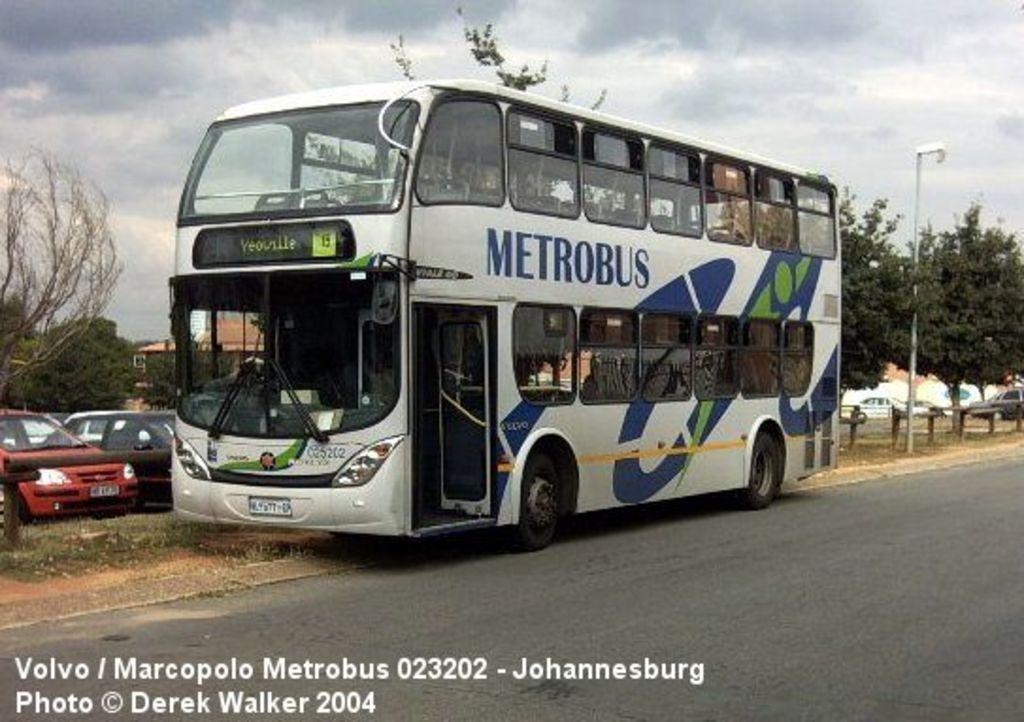Please provide a concise description of this image. There is a road. Near to the road there is a double decker bus. On the bus something is written. Also there is a name board. Near to the bus there are vehicles, trees and a pole. In the background there is sky with clouds. In the left bottom corner there is a watermark. 